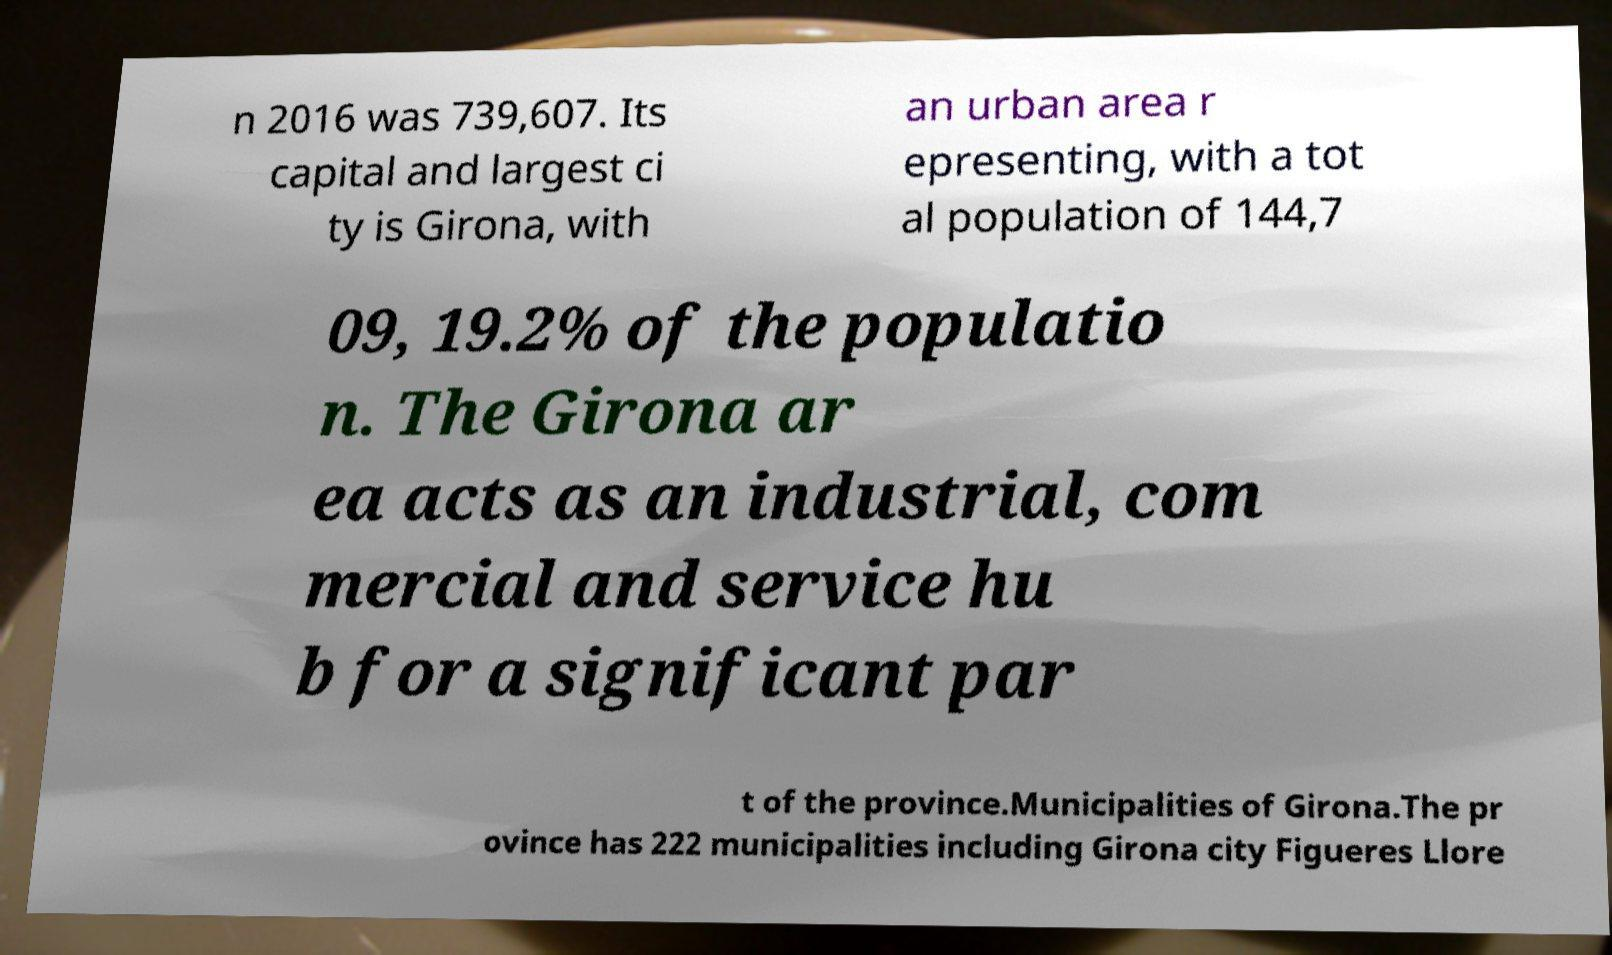What messages or text are displayed in this image? I need them in a readable, typed format. n 2016 was 739,607. Its capital and largest ci ty is Girona, with an urban area r epresenting, with a tot al population of 144,7 09, 19.2% of the populatio n. The Girona ar ea acts as an industrial, com mercial and service hu b for a significant par t of the province.Municipalities of Girona.The pr ovince has 222 municipalities including Girona city Figueres Llore 